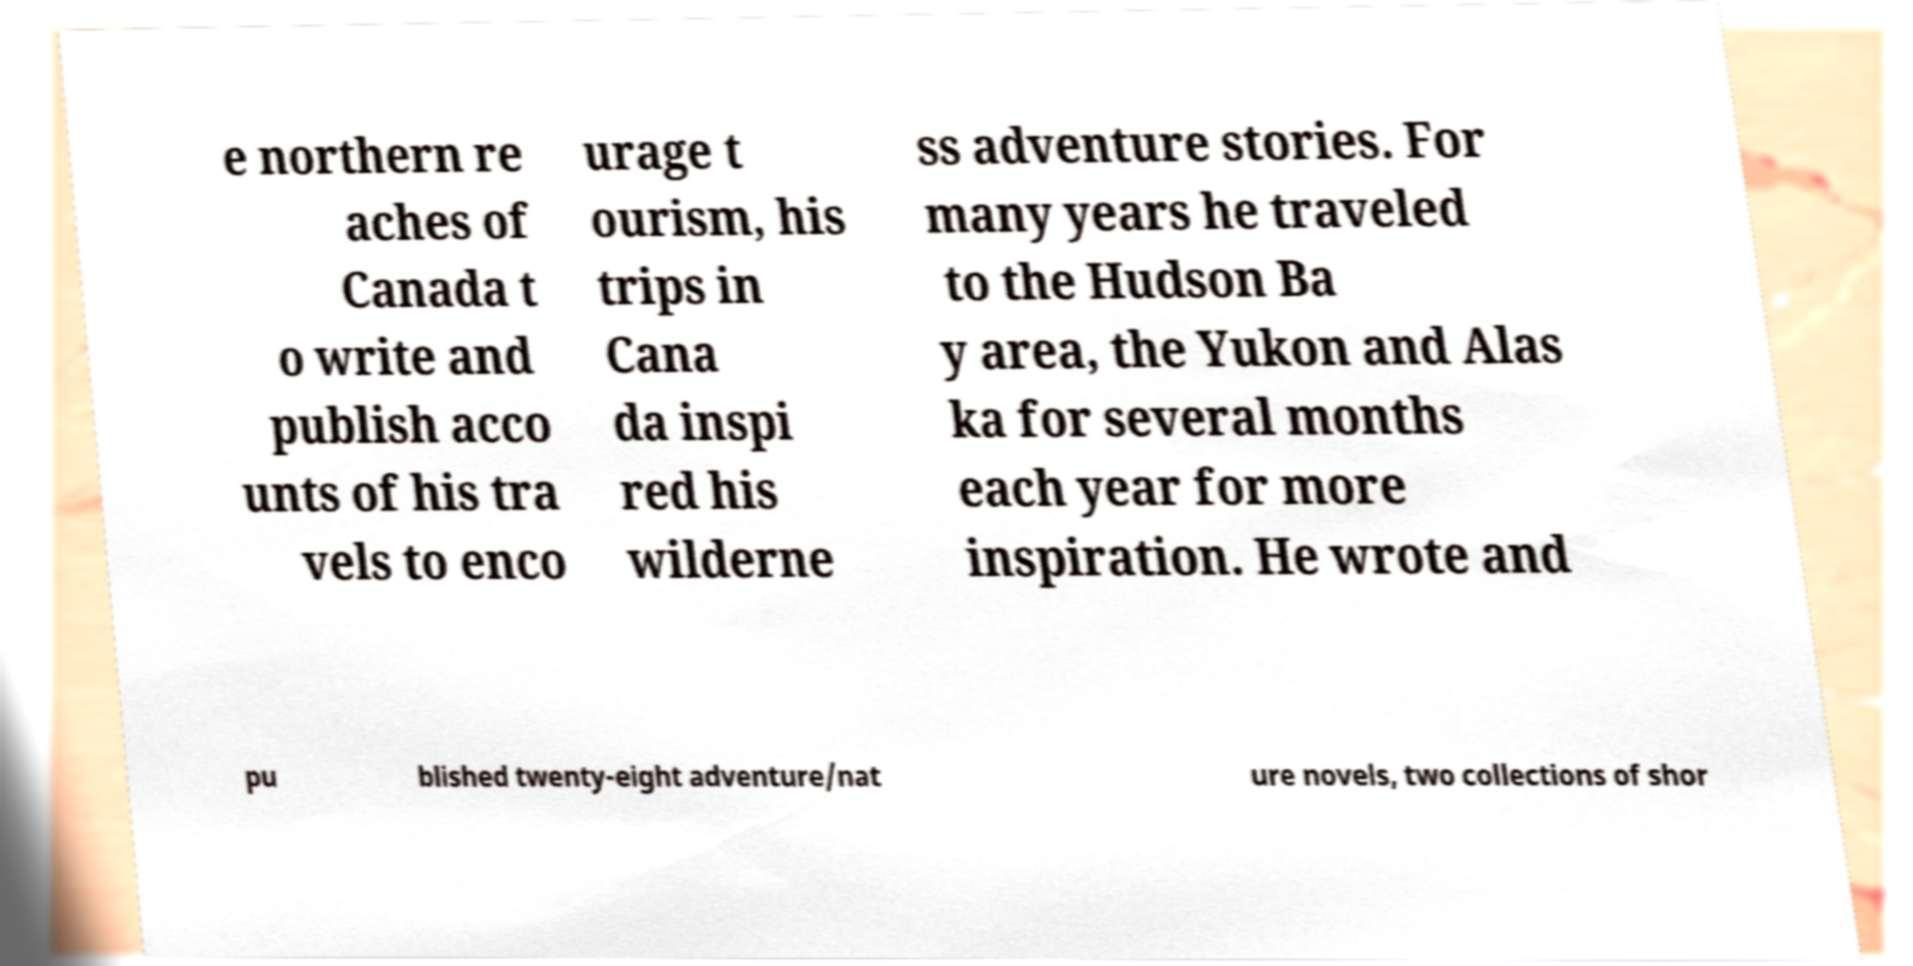I need the written content from this picture converted into text. Can you do that? e northern re aches of Canada t o write and publish acco unts of his tra vels to enco urage t ourism, his trips in Cana da inspi red his wilderne ss adventure stories. For many years he traveled to the Hudson Ba y area, the Yukon and Alas ka for several months each year for more inspiration. He wrote and pu blished twenty-eight adventure/nat ure novels, two collections of shor 